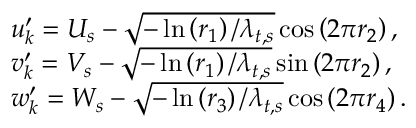Convert formula to latex. <formula><loc_0><loc_0><loc_500><loc_500>\begin{array} { r l } & { u _ { k } ^ { \prime } = U _ { s } - \sqrt { - \ln \left ( r _ { 1 } \right ) / \lambda _ { t , s } } \cos \left ( 2 \pi r _ { 2 } \right ) , } \\ & { v _ { k } ^ { \prime } = V _ { s } - \sqrt { - \ln \left ( r _ { 1 } \right ) / \lambda _ { t , s } } \sin \left ( 2 \pi r _ { 2 } \right ) , } \\ & { w _ { k } ^ { \prime } = W _ { s } - \sqrt { - \ln \left ( r _ { 3 } \right ) / \lambda _ { t , s } } \cos \left ( 2 \pi r _ { 4 } \right ) . } \end{array}</formula> 